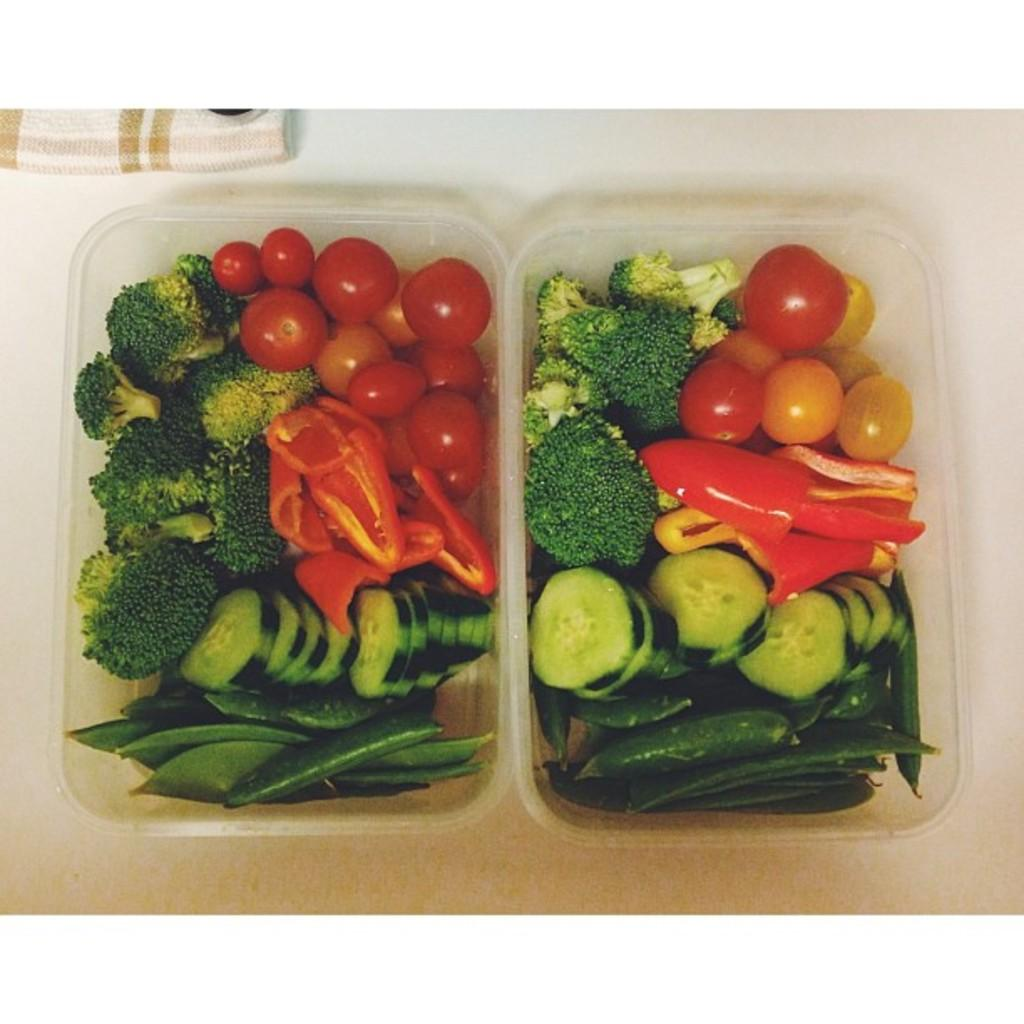What types of food are in the baskets in the image? There are vegetables in two baskets in the image. What is the color of the surface on which the baskets are placed? The baskets are on a white surface. Can you describe the cloth that is visible in the image? There is cloth on the top of the image. What song is being sung by the vegetables in the image? There are no vegetables singing in the image; they are simply vegetables in baskets. 